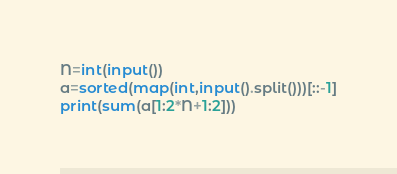<code> <loc_0><loc_0><loc_500><loc_500><_Python_>N=int(input())
a=sorted(map(int,input().split()))[::-1]
print(sum(a[1:2*N+1:2]))</code> 